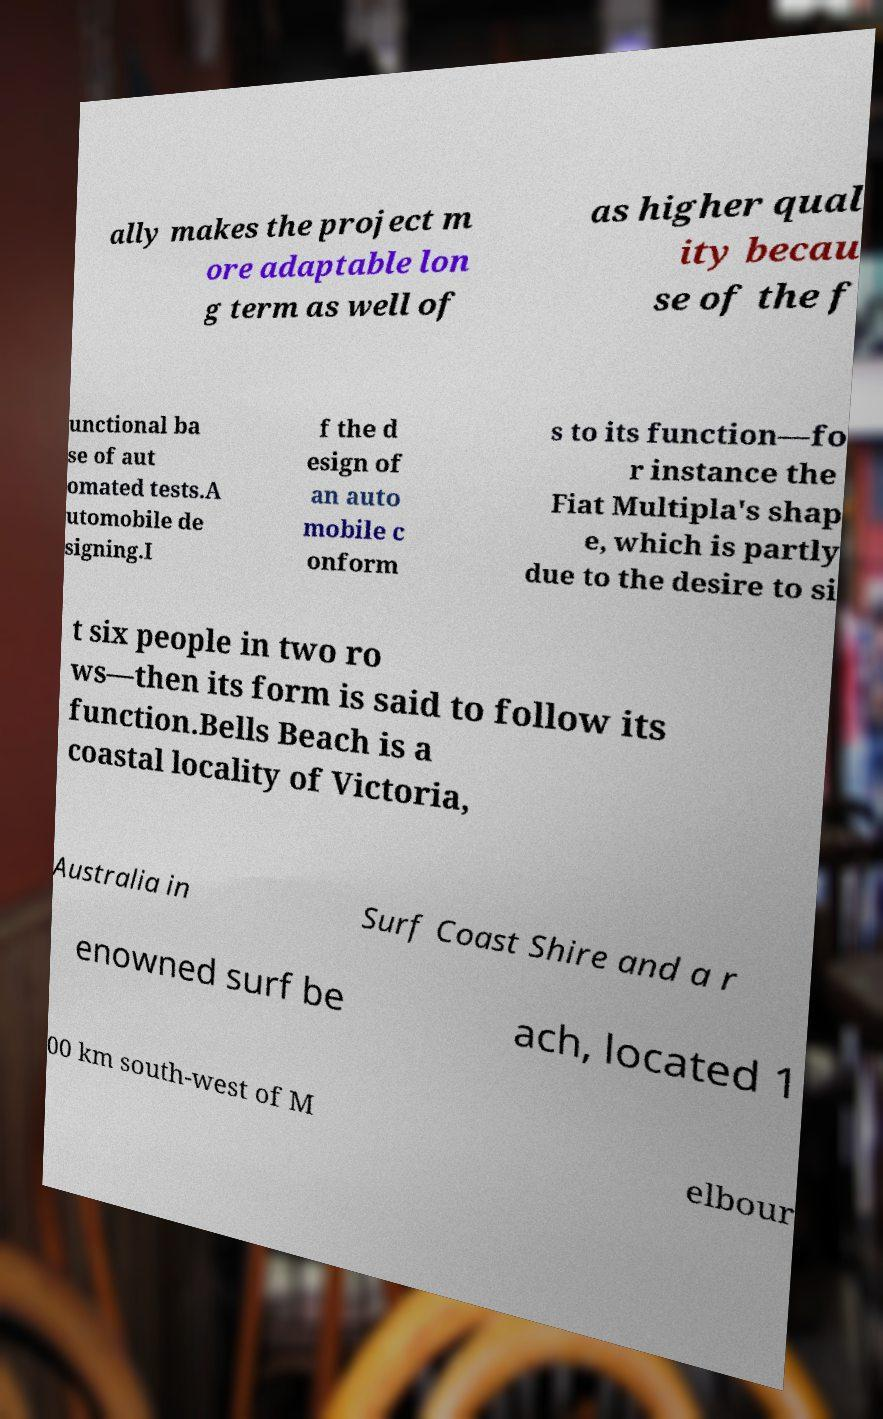Can you read and provide the text displayed in the image?This photo seems to have some interesting text. Can you extract and type it out for me? ally makes the project m ore adaptable lon g term as well of as higher qual ity becau se of the f unctional ba se of aut omated tests.A utomobile de signing.I f the d esign of an auto mobile c onform s to its function—fo r instance the Fiat Multipla's shap e, which is partly due to the desire to si t six people in two ro ws—then its form is said to follow its function.Bells Beach is a coastal locality of Victoria, Australia in Surf Coast Shire and a r enowned surf be ach, located 1 00 km south-west of M elbour 